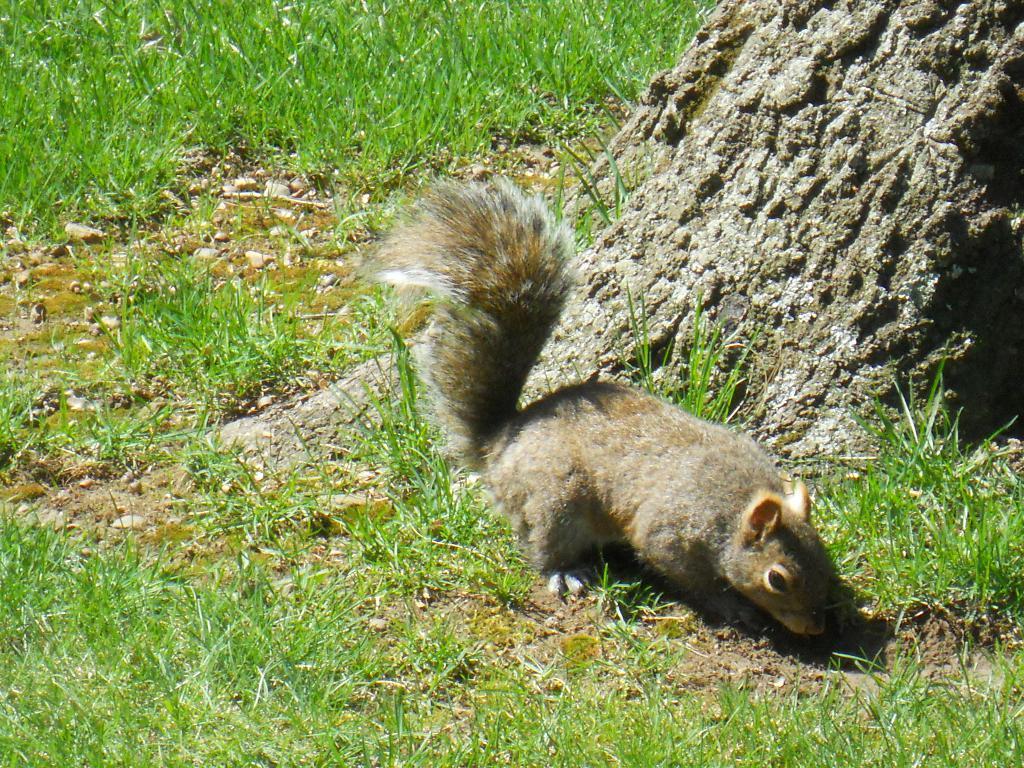In one or two sentences, can you explain what this image depicts? In the foreground of the picture there are grass, soil, stones, squirrel and the trunk of a tree. At the top there is grass. 